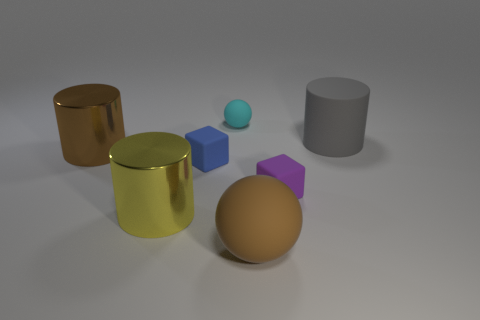The object that is behind the small blue object and on the left side of the small blue block is made of what material?
Provide a succinct answer. Metal. What is the color of the tiny block right of the large brown ball?
Keep it short and to the point. Purple. Is the number of big matte things in front of the large brown ball greater than the number of cubes?
Provide a succinct answer. No. How many other things are there of the same size as the brown shiny cylinder?
Offer a terse response. 3. How many purple cubes are in front of the big brown rubber object?
Your answer should be very brief. 0. Are there the same number of brown matte balls behind the small blue matte cube and large metallic objects behind the large yellow object?
Your answer should be compact. No. What is the size of the purple matte object that is the same shape as the small blue rubber object?
Make the answer very short. Small. What is the shape of the small object behind the big gray object?
Your answer should be very brief. Sphere. Are the big brown thing that is in front of the purple matte object and the brown thing that is behind the brown ball made of the same material?
Provide a succinct answer. No. What is the shape of the large gray object?
Your response must be concise. Cylinder. 